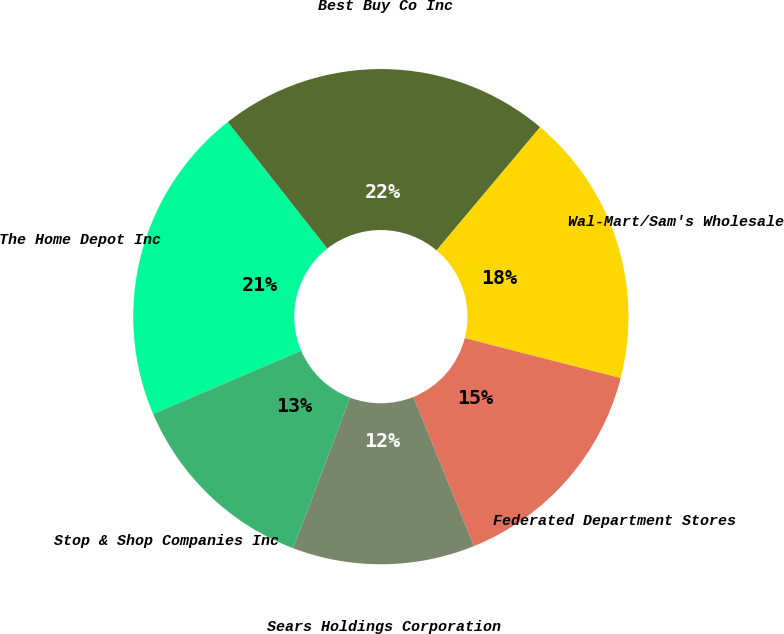<chart> <loc_0><loc_0><loc_500><loc_500><pie_chart><fcel>The Home Depot Inc<fcel>Best Buy Co Inc<fcel>Wal-Mart/Sam's Wholesale<fcel>Federated Department Stores<fcel>Sears Holdings Corporation<fcel>Stop & Shop Companies Inc<nl><fcel>20.83%<fcel>21.73%<fcel>17.86%<fcel>14.88%<fcel>11.9%<fcel>12.8%<nl></chart> 